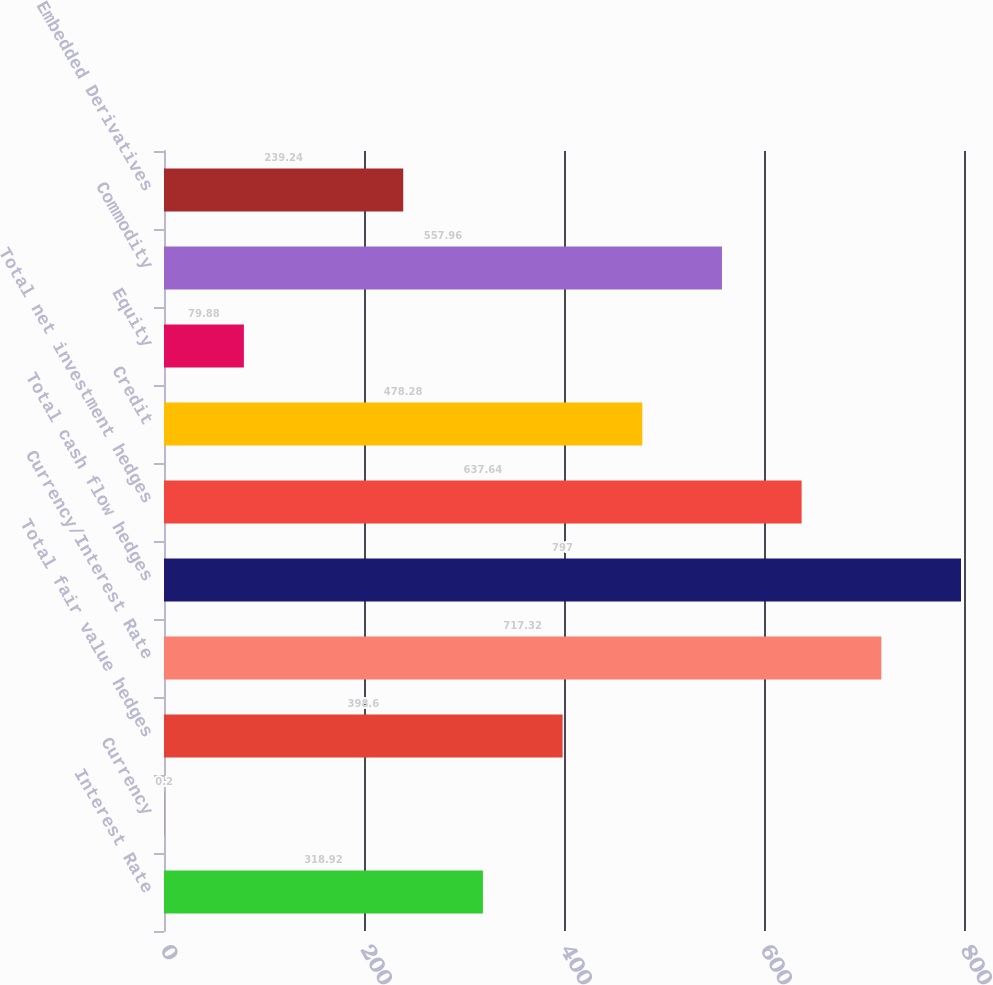Convert chart. <chart><loc_0><loc_0><loc_500><loc_500><bar_chart><fcel>Interest Rate<fcel>Currency<fcel>Total fair value hedges<fcel>Currency/Interest Rate<fcel>Total cash flow hedges<fcel>Total net investment hedges<fcel>Credit<fcel>Equity<fcel>Commodity<fcel>Embedded Derivatives<nl><fcel>318.92<fcel>0.2<fcel>398.6<fcel>717.32<fcel>797<fcel>637.64<fcel>478.28<fcel>79.88<fcel>557.96<fcel>239.24<nl></chart> 